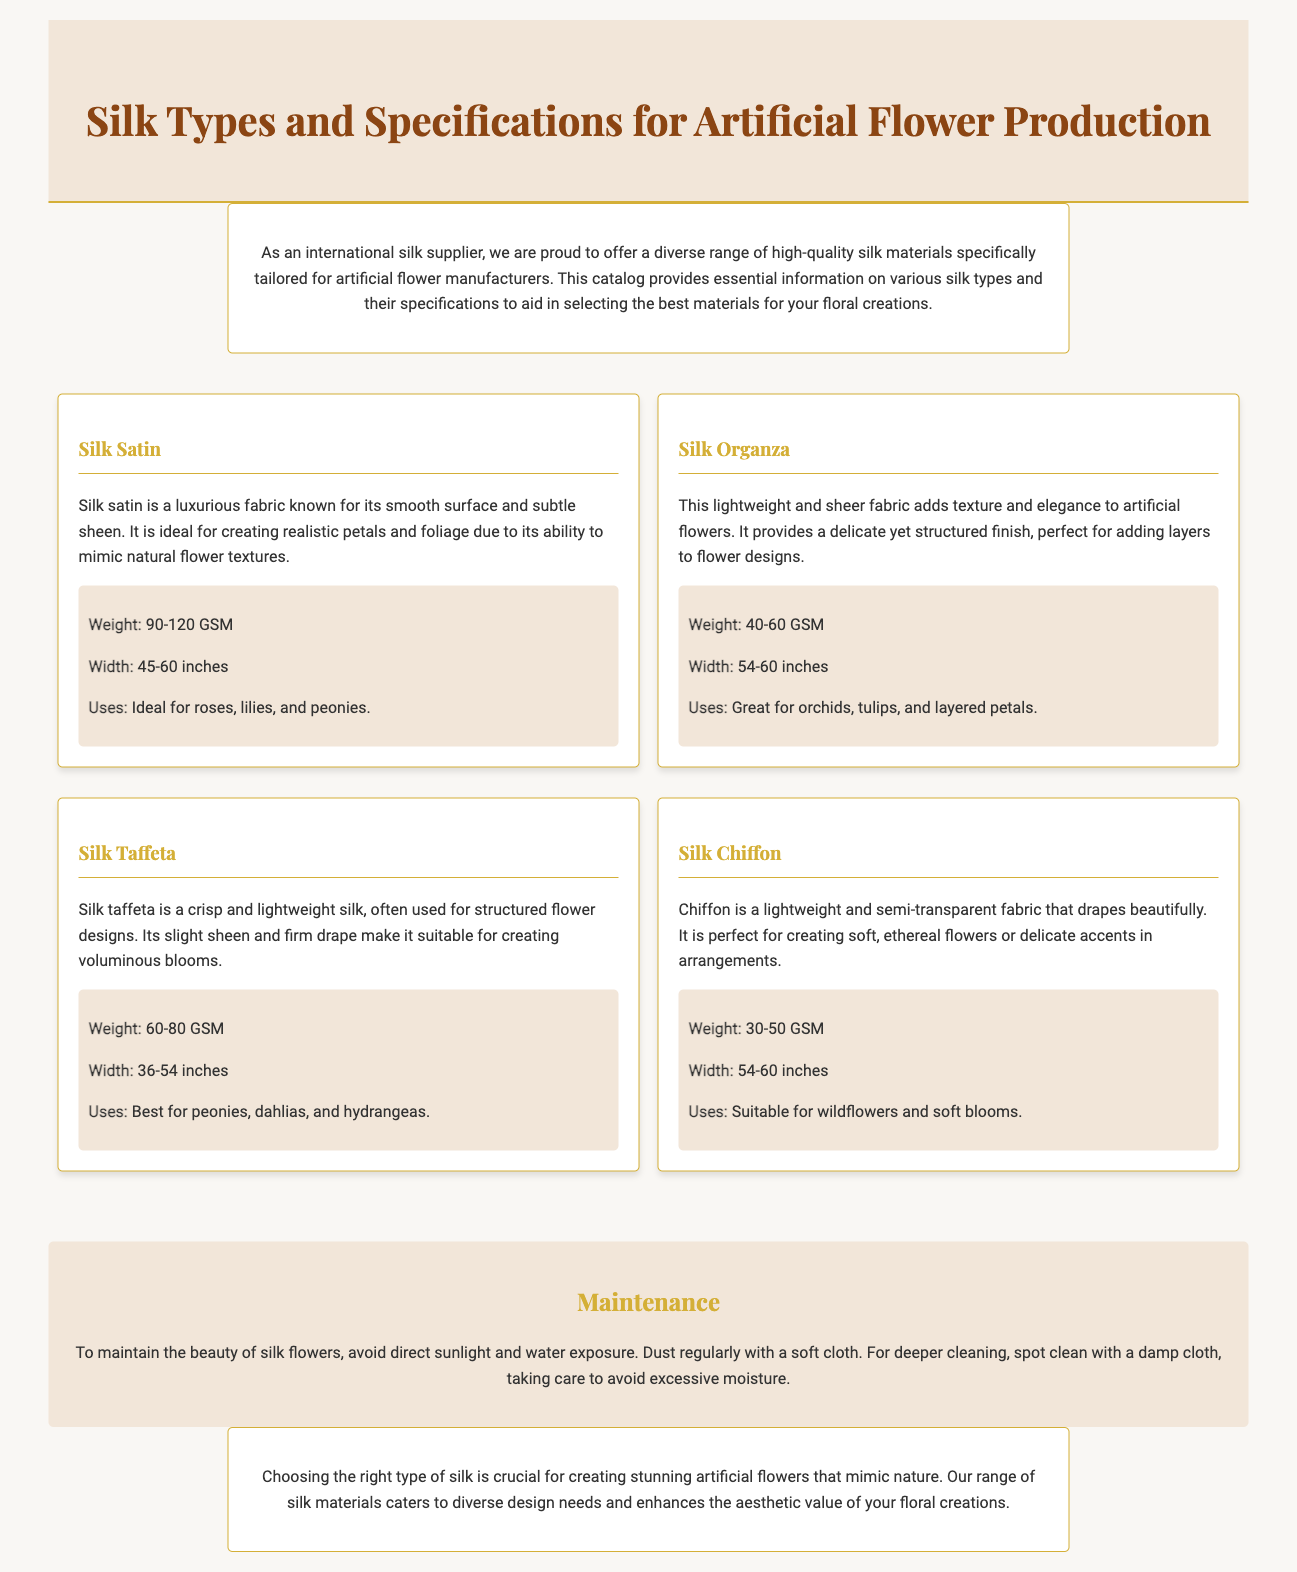What is the weight range for Silk Satin? The weight range for Silk Satin is specified in the document as 90-120 GSM.
Answer: 90-120 GSM What is the width of Silk Organza? The width of Silk Organza is mentioned as 54-60 inches in the document.
Answer: 54-60 inches Which silk type is ideal for roses, lilies, and peonies? The document states that Silk Satin is ideal for roses, lilies, and peonies.
Answer: Silk Satin What is the weight range of Silk Chiffon? The document mentions the weight range of Silk Chiffon as 30-50 GSM.
Answer: 30-50 GSM What type of silk is suitable for wildflowers? According to the document, Silk Chiffon is suitable for wildflowers.
Answer: Silk Chiffon Why is Silk Taffeta preferred for voluminous blooms? Silk Taffeta is preferred for voluminous blooms because of its crisp and lightweight nature, as per the document.
Answer: Crisp and lightweight nature What maintenance tip is provided for silk flowers? The document advises to avoid direct sunlight and water exposure to maintain silk flowers.
Answer: Avoid direct sunlight and water exposure What color is recommended for the silk types heading? The document states that the silk types heading is in the color #d4af37.
Answer: #d4af37 How many types of silk are mentioned in the document? The document outlines a total of four types of silk for artificial flower production.
Answer: Four types 